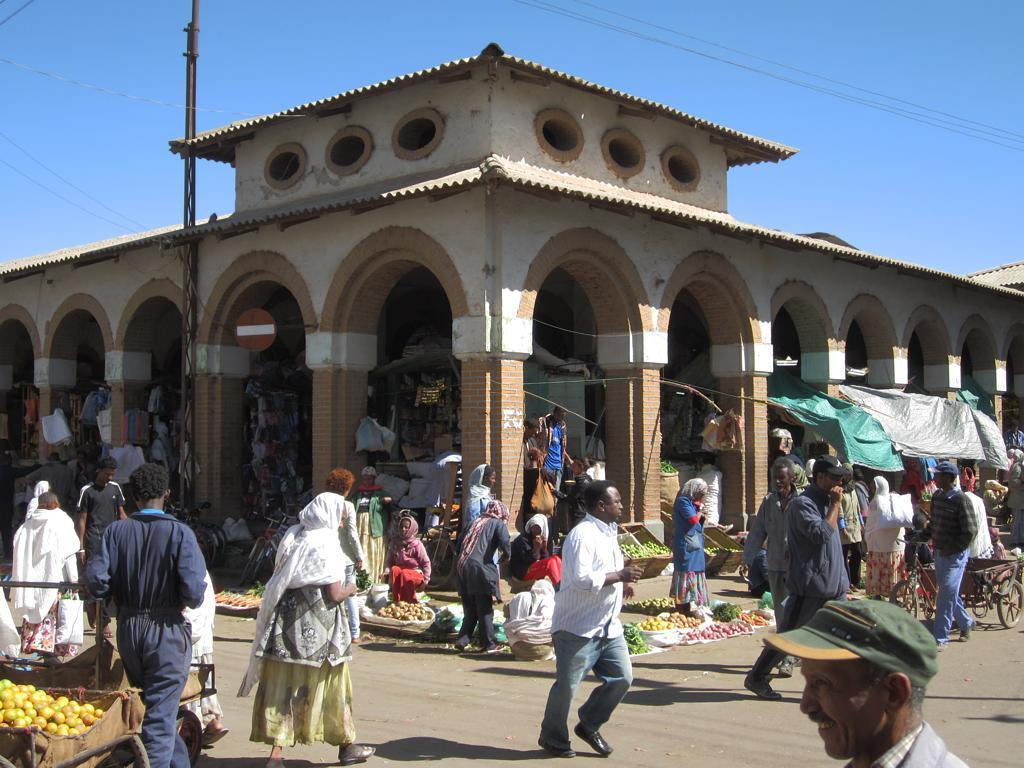What are the people in the image doing? The persons in the image are walking on the road. What else can be seen in the image besides the people? There are vegetables and food items visible in the image. What is located in the background of the image? There is a building in the background of the image. What is visible at the top of the image? The sky is visible at the top of the image. Where is the church located in the image? There is no church present in the image. Can you see a nest in the image? There is no nest visible in the image. 